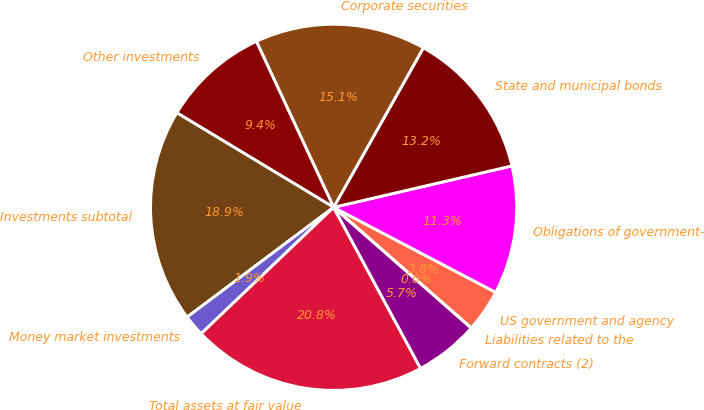Convert chart to OTSL. <chart><loc_0><loc_0><loc_500><loc_500><pie_chart><fcel>US government and agency<fcel>Obligations of government-<fcel>State and municipal bonds<fcel>Corporate securities<fcel>Other investments<fcel>Investments subtotal<fcel>Money market investments<fcel>Total assets at fair value<fcel>Forward contracts (2)<fcel>Liabilities related to the<nl><fcel>3.77%<fcel>11.32%<fcel>13.21%<fcel>15.09%<fcel>9.43%<fcel>18.87%<fcel>1.89%<fcel>20.75%<fcel>5.66%<fcel>0.0%<nl></chart> 